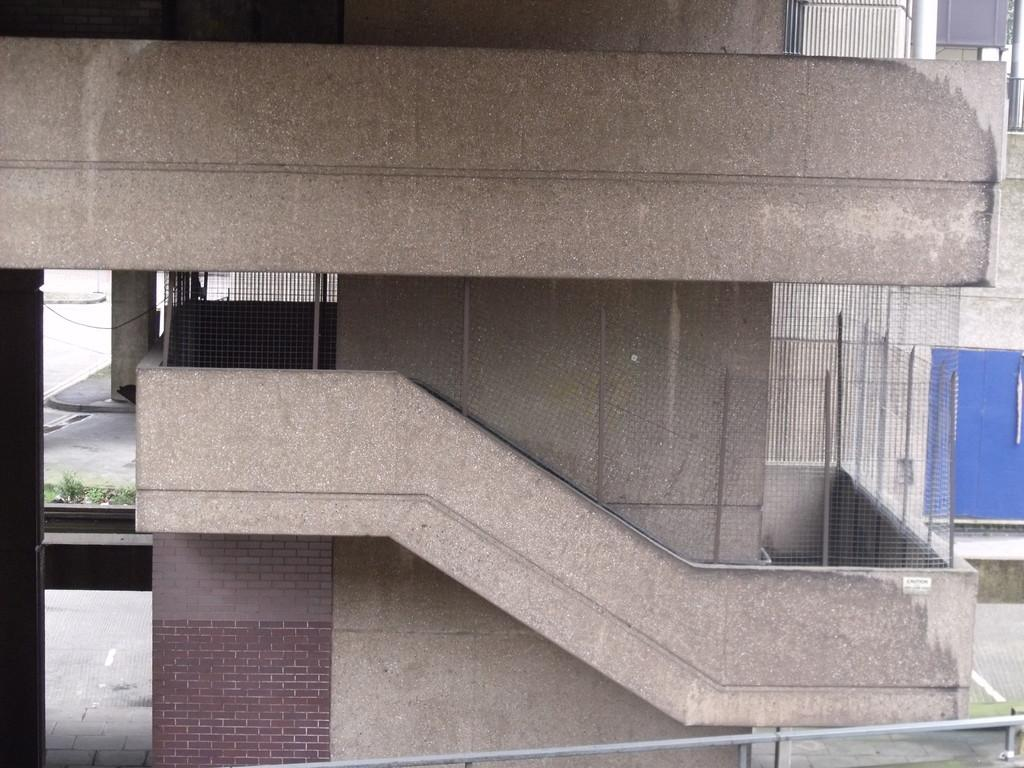What type of structure is visible in the image? There is a building in the image. What is separating the building from the surrounding area? There is a wire fence in the image. What type of vegetation can be seen in the image? There are plants in the image. What type of joke can be seen in the image? There is no joke present in the image. What type of vessel is being used to transport the plants in the image? There is no vessel present in the image, and the plants are not being transported. 